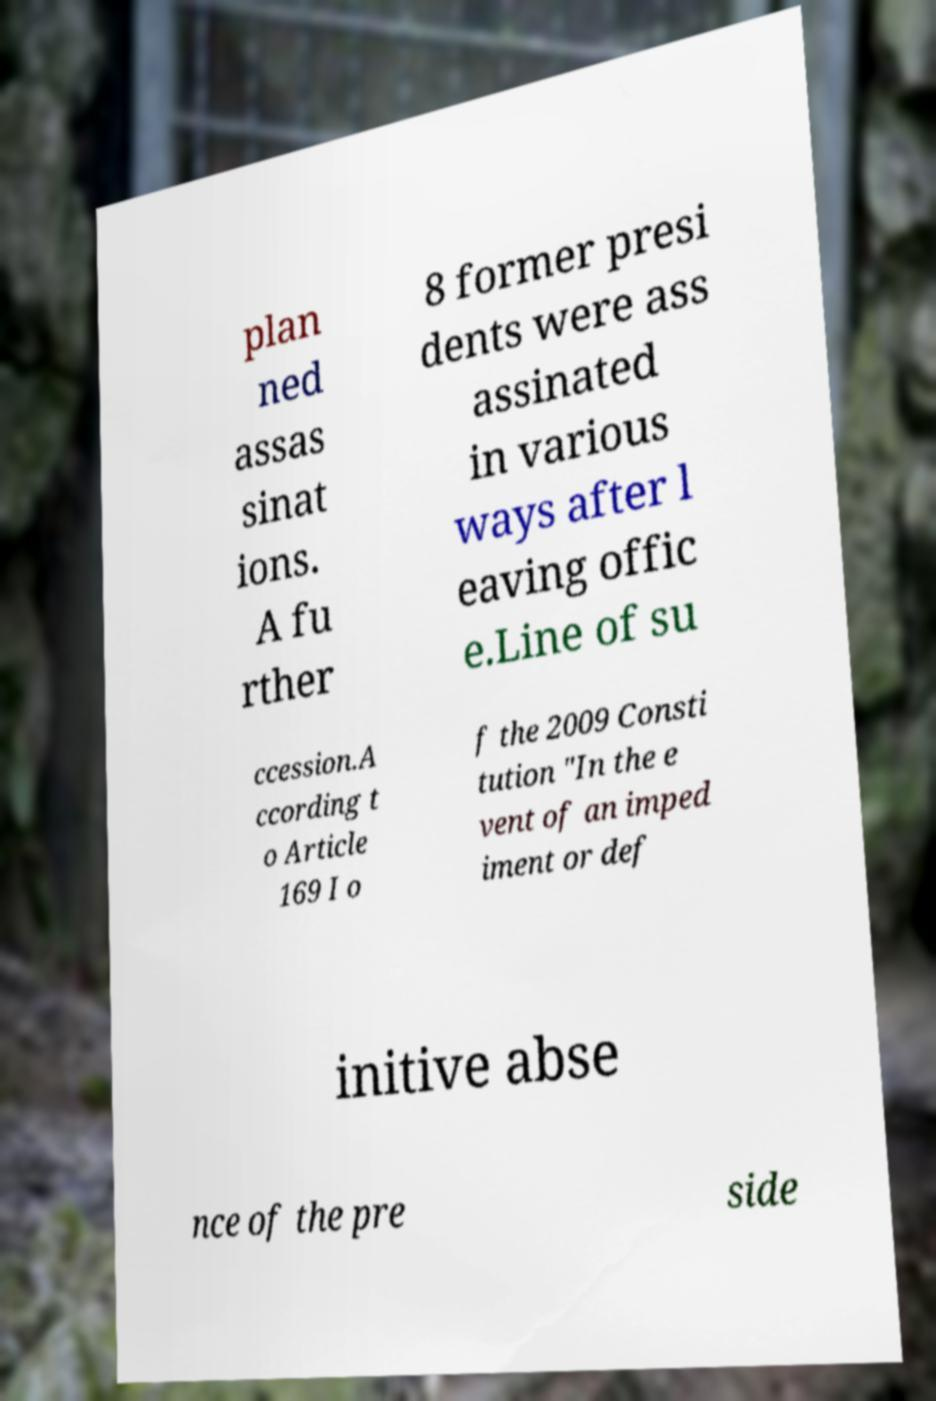Can you accurately transcribe the text from the provided image for me? plan ned assas sinat ions. A fu rther 8 former presi dents were ass assinated in various ways after l eaving offic e.Line of su ccession.A ccording t o Article 169 I o f the 2009 Consti tution "In the e vent of an imped iment or def initive abse nce of the pre side 